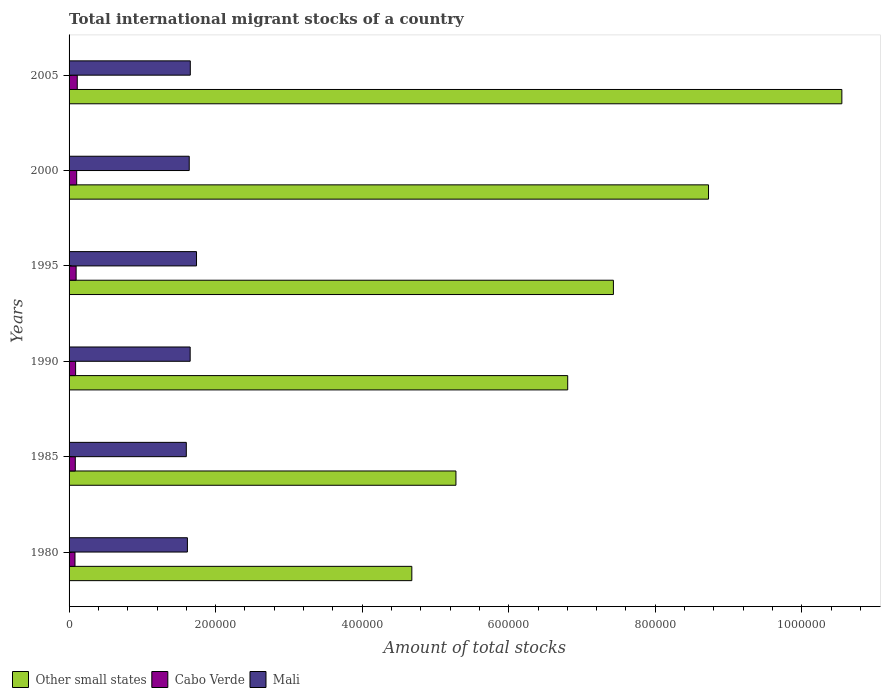How many different coloured bars are there?
Make the answer very short. 3. Are the number of bars per tick equal to the number of legend labels?
Make the answer very short. Yes. Are the number of bars on each tick of the Y-axis equal?
Provide a succinct answer. Yes. What is the label of the 1st group of bars from the top?
Your response must be concise. 2005. What is the amount of total stocks in in Mali in 1990?
Make the answer very short. 1.65e+05. Across all years, what is the maximum amount of total stocks in in Cabo Verde?
Give a very brief answer. 1.12e+04. Across all years, what is the minimum amount of total stocks in in Cabo Verde?
Your answer should be compact. 8080. In which year was the amount of total stocks in in Other small states maximum?
Provide a succinct answer. 2005. What is the total amount of total stocks in in Cabo Verde in the graph?
Your response must be concise. 5.67e+04. What is the difference between the amount of total stocks in in Other small states in 1985 and that in 2005?
Keep it short and to the point. -5.27e+05. What is the difference between the amount of total stocks in in Cabo Verde in 2005 and the amount of total stocks in in Mali in 1995?
Your answer should be compact. -1.63e+05. What is the average amount of total stocks in in Cabo Verde per year?
Your response must be concise. 9448.33. In the year 1990, what is the difference between the amount of total stocks in in Other small states and amount of total stocks in in Cabo Verde?
Your answer should be compact. 6.72e+05. In how many years, is the amount of total stocks in in Cabo Verde greater than 640000 ?
Keep it short and to the point. 0. What is the ratio of the amount of total stocks in in Mali in 1995 to that in 2005?
Provide a short and direct response. 1.05. Is the difference between the amount of total stocks in in Other small states in 1980 and 1985 greater than the difference between the amount of total stocks in in Cabo Verde in 1980 and 1985?
Give a very brief answer. No. What is the difference between the highest and the second highest amount of total stocks in in Mali?
Your response must be concise. 8494. What is the difference between the highest and the lowest amount of total stocks in in Mali?
Provide a short and direct response. 1.39e+04. Is the sum of the amount of total stocks in in Other small states in 1980 and 1990 greater than the maximum amount of total stocks in in Cabo Verde across all years?
Your answer should be compact. Yes. What does the 3rd bar from the top in 1995 represents?
Your answer should be very brief. Other small states. What does the 2nd bar from the bottom in 2005 represents?
Provide a short and direct response. Cabo Verde. Is it the case that in every year, the sum of the amount of total stocks in in Cabo Verde and amount of total stocks in in Mali is greater than the amount of total stocks in in Other small states?
Make the answer very short. No. Are all the bars in the graph horizontal?
Your answer should be compact. Yes. How many years are there in the graph?
Keep it short and to the point. 6. What is the difference between two consecutive major ticks on the X-axis?
Ensure brevity in your answer.  2.00e+05. Where does the legend appear in the graph?
Offer a very short reply. Bottom left. How are the legend labels stacked?
Offer a terse response. Horizontal. What is the title of the graph?
Offer a terse response. Total international migrant stocks of a country. What is the label or title of the X-axis?
Your response must be concise. Amount of total stocks. What is the label or title of the Y-axis?
Keep it short and to the point. Years. What is the Amount of total stocks in Other small states in 1980?
Provide a short and direct response. 4.68e+05. What is the Amount of total stocks of Cabo Verde in 1980?
Offer a very short reply. 8080. What is the Amount of total stocks in Mali in 1980?
Your answer should be very brief. 1.62e+05. What is the Amount of total stocks in Other small states in 1985?
Make the answer very short. 5.28e+05. What is the Amount of total stocks of Cabo Verde in 1985?
Provide a succinct answer. 8495. What is the Amount of total stocks of Mali in 1985?
Make the answer very short. 1.60e+05. What is the Amount of total stocks of Other small states in 1990?
Provide a short and direct response. 6.81e+05. What is the Amount of total stocks in Cabo Verde in 1990?
Make the answer very short. 8931. What is the Amount of total stocks of Mali in 1990?
Your response must be concise. 1.65e+05. What is the Amount of total stocks in Other small states in 1995?
Ensure brevity in your answer.  7.43e+05. What is the Amount of total stocks of Cabo Verde in 1995?
Give a very brief answer. 9626. What is the Amount of total stocks of Mali in 1995?
Offer a terse response. 1.74e+05. What is the Amount of total stocks in Other small states in 2000?
Offer a very short reply. 8.73e+05. What is the Amount of total stocks in Cabo Verde in 2000?
Your answer should be very brief. 1.04e+04. What is the Amount of total stocks of Mali in 2000?
Offer a very short reply. 1.64e+05. What is the Amount of total stocks in Other small states in 2005?
Your answer should be very brief. 1.05e+06. What is the Amount of total stocks in Cabo Verde in 2005?
Make the answer very short. 1.12e+04. What is the Amount of total stocks in Mali in 2005?
Give a very brief answer. 1.65e+05. Across all years, what is the maximum Amount of total stocks in Other small states?
Your response must be concise. 1.05e+06. Across all years, what is the maximum Amount of total stocks in Cabo Verde?
Offer a very short reply. 1.12e+04. Across all years, what is the maximum Amount of total stocks of Mali?
Ensure brevity in your answer.  1.74e+05. Across all years, what is the minimum Amount of total stocks in Other small states?
Your answer should be very brief. 4.68e+05. Across all years, what is the minimum Amount of total stocks of Cabo Verde?
Offer a very short reply. 8080. Across all years, what is the minimum Amount of total stocks in Mali?
Make the answer very short. 1.60e+05. What is the total Amount of total stocks of Other small states in the graph?
Give a very brief answer. 4.35e+06. What is the total Amount of total stocks in Cabo Verde in the graph?
Ensure brevity in your answer.  5.67e+04. What is the total Amount of total stocks in Mali in the graph?
Offer a very short reply. 9.90e+05. What is the difference between the Amount of total stocks in Other small states in 1980 and that in 1985?
Your answer should be compact. -6.02e+04. What is the difference between the Amount of total stocks in Cabo Verde in 1980 and that in 1985?
Offer a terse response. -415. What is the difference between the Amount of total stocks in Mali in 1980 and that in 1985?
Offer a terse response. 1487. What is the difference between the Amount of total stocks in Other small states in 1980 and that in 1990?
Offer a very short reply. -2.13e+05. What is the difference between the Amount of total stocks in Cabo Verde in 1980 and that in 1990?
Keep it short and to the point. -851. What is the difference between the Amount of total stocks in Mali in 1980 and that in 1990?
Offer a terse response. -3769. What is the difference between the Amount of total stocks of Other small states in 1980 and that in 1995?
Your answer should be very brief. -2.75e+05. What is the difference between the Amount of total stocks in Cabo Verde in 1980 and that in 1995?
Offer a very short reply. -1546. What is the difference between the Amount of total stocks in Mali in 1980 and that in 1995?
Keep it short and to the point. -1.24e+04. What is the difference between the Amount of total stocks of Other small states in 1980 and that in 2000?
Your answer should be compact. -4.05e+05. What is the difference between the Amount of total stocks of Cabo Verde in 1980 and that in 2000?
Your response must be concise. -2295. What is the difference between the Amount of total stocks in Mali in 1980 and that in 2000?
Give a very brief answer. -2488. What is the difference between the Amount of total stocks in Other small states in 1980 and that in 2005?
Your answer should be compact. -5.87e+05. What is the difference between the Amount of total stocks in Cabo Verde in 1980 and that in 2005?
Give a very brief answer. -3103. What is the difference between the Amount of total stocks of Mali in 1980 and that in 2005?
Your answer should be compact. -3942. What is the difference between the Amount of total stocks in Other small states in 1985 and that in 1990?
Make the answer very short. -1.53e+05. What is the difference between the Amount of total stocks in Cabo Verde in 1985 and that in 1990?
Give a very brief answer. -436. What is the difference between the Amount of total stocks of Mali in 1985 and that in 1990?
Keep it short and to the point. -5256. What is the difference between the Amount of total stocks in Other small states in 1985 and that in 1995?
Give a very brief answer. -2.15e+05. What is the difference between the Amount of total stocks in Cabo Verde in 1985 and that in 1995?
Give a very brief answer. -1131. What is the difference between the Amount of total stocks in Mali in 1985 and that in 1995?
Ensure brevity in your answer.  -1.39e+04. What is the difference between the Amount of total stocks in Other small states in 1985 and that in 2000?
Make the answer very short. -3.45e+05. What is the difference between the Amount of total stocks of Cabo Verde in 1985 and that in 2000?
Offer a terse response. -1880. What is the difference between the Amount of total stocks of Mali in 1985 and that in 2000?
Provide a succinct answer. -3975. What is the difference between the Amount of total stocks in Other small states in 1985 and that in 2005?
Make the answer very short. -5.27e+05. What is the difference between the Amount of total stocks of Cabo Verde in 1985 and that in 2005?
Your answer should be compact. -2688. What is the difference between the Amount of total stocks of Mali in 1985 and that in 2005?
Make the answer very short. -5429. What is the difference between the Amount of total stocks in Other small states in 1990 and that in 1995?
Keep it short and to the point. -6.24e+04. What is the difference between the Amount of total stocks of Cabo Verde in 1990 and that in 1995?
Give a very brief answer. -695. What is the difference between the Amount of total stocks in Mali in 1990 and that in 1995?
Keep it short and to the point. -8667. What is the difference between the Amount of total stocks in Other small states in 1990 and that in 2000?
Make the answer very short. -1.92e+05. What is the difference between the Amount of total stocks in Cabo Verde in 1990 and that in 2000?
Make the answer very short. -1444. What is the difference between the Amount of total stocks in Mali in 1990 and that in 2000?
Make the answer very short. 1281. What is the difference between the Amount of total stocks in Other small states in 1990 and that in 2005?
Keep it short and to the point. -3.74e+05. What is the difference between the Amount of total stocks of Cabo Verde in 1990 and that in 2005?
Keep it short and to the point. -2252. What is the difference between the Amount of total stocks of Mali in 1990 and that in 2005?
Provide a succinct answer. -173. What is the difference between the Amount of total stocks in Other small states in 1995 and that in 2000?
Your response must be concise. -1.30e+05. What is the difference between the Amount of total stocks of Cabo Verde in 1995 and that in 2000?
Offer a terse response. -749. What is the difference between the Amount of total stocks in Mali in 1995 and that in 2000?
Offer a very short reply. 9948. What is the difference between the Amount of total stocks in Other small states in 1995 and that in 2005?
Give a very brief answer. -3.12e+05. What is the difference between the Amount of total stocks of Cabo Verde in 1995 and that in 2005?
Give a very brief answer. -1557. What is the difference between the Amount of total stocks of Mali in 1995 and that in 2005?
Provide a succinct answer. 8494. What is the difference between the Amount of total stocks in Other small states in 2000 and that in 2005?
Provide a succinct answer. -1.82e+05. What is the difference between the Amount of total stocks of Cabo Verde in 2000 and that in 2005?
Ensure brevity in your answer.  -808. What is the difference between the Amount of total stocks of Mali in 2000 and that in 2005?
Give a very brief answer. -1454. What is the difference between the Amount of total stocks of Other small states in 1980 and the Amount of total stocks of Cabo Verde in 1985?
Your response must be concise. 4.59e+05. What is the difference between the Amount of total stocks in Other small states in 1980 and the Amount of total stocks in Mali in 1985?
Ensure brevity in your answer.  3.08e+05. What is the difference between the Amount of total stocks in Cabo Verde in 1980 and the Amount of total stocks in Mali in 1985?
Provide a succinct answer. -1.52e+05. What is the difference between the Amount of total stocks in Other small states in 1980 and the Amount of total stocks in Cabo Verde in 1990?
Your response must be concise. 4.59e+05. What is the difference between the Amount of total stocks of Other small states in 1980 and the Amount of total stocks of Mali in 1990?
Make the answer very short. 3.03e+05. What is the difference between the Amount of total stocks of Cabo Verde in 1980 and the Amount of total stocks of Mali in 1990?
Offer a very short reply. -1.57e+05. What is the difference between the Amount of total stocks in Other small states in 1980 and the Amount of total stocks in Cabo Verde in 1995?
Offer a very short reply. 4.58e+05. What is the difference between the Amount of total stocks in Other small states in 1980 and the Amount of total stocks in Mali in 1995?
Keep it short and to the point. 2.94e+05. What is the difference between the Amount of total stocks of Cabo Verde in 1980 and the Amount of total stocks of Mali in 1995?
Your answer should be compact. -1.66e+05. What is the difference between the Amount of total stocks of Other small states in 1980 and the Amount of total stocks of Cabo Verde in 2000?
Make the answer very short. 4.57e+05. What is the difference between the Amount of total stocks in Other small states in 1980 and the Amount of total stocks in Mali in 2000?
Provide a succinct answer. 3.04e+05. What is the difference between the Amount of total stocks of Cabo Verde in 1980 and the Amount of total stocks of Mali in 2000?
Your answer should be compact. -1.56e+05. What is the difference between the Amount of total stocks in Other small states in 1980 and the Amount of total stocks in Cabo Verde in 2005?
Ensure brevity in your answer.  4.57e+05. What is the difference between the Amount of total stocks in Other small states in 1980 and the Amount of total stocks in Mali in 2005?
Make the answer very short. 3.02e+05. What is the difference between the Amount of total stocks in Cabo Verde in 1980 and the Amount of total stocks in Mali in 2005?
Your response must be concise. -1.57e+05. What is the difference between the Amount of total stocks of Other small states in 1985 and the Amount of total stocks of Cabo Verde in 1990?
Your answer should be very brief. 5.19e+05. What is the difference between the Amount of total stocks of Other small states in 1985 and the Amount of total stocks of Mali in 1990?
Your answer should be compact. 3.63e+05. What is the difference between the Amount of total stocks in Cabo Verde in 1985 and the Amount of total stocks in Mali in 1990?
Your answer should be compact. -1.57e+05. What is the difference between the Amount of total stocks of Other small states in 1985 and the Amount of total stocks of Cabo Verde in 1995?
Provide a succinct answer. 5.18e+05. What is the difference between the Amount of total stocks of Other small states in 1985 and the Amount of total stocks of Mali in 1995?
Offer a terse response. 3.54e+05. What is the difference between the Amount of total stocks in Cabo Verde in 1985 and the Amount of total stocks in Mali in 1995?
Offer a very short reply. -1.65e+05. What is the difference between the Amount of total stocks of Other small states in 1985 and the Amount of total stocks of Cabo Verde in 2000?
Make the answer very short. 5.18e+05. What is the difference between the Amount of total stocks in Other small states in 1985 and the Amount of total stocks in Mali in 2000?
Provide a succinct answer. 3.64e+05. What is the difference between the Amount of total stocks in Cabo Verde in 1985 and the Amount of total stocks in Mali in 2000?
Your answer should be compact. -1.55e+05. What is the difference between the Amount of total stocks in Other small states in 1985 and the Amount of total stocks in Cabo Verde in 2005?
Provide a succinct answer. 5.17e+05. What is the difference between the Amount of total stocks of Other small states in 1985 and the Amount of total stocks of Mali in 2005?
Keep it short and to the point. 3.63e+05. What is the difference between the Amount of total stocks in Cabo Verde in 1985 and the Amount of total stocks in Mali in 2005?
Your response must be concise. -1.57e+05. What is the difference between the Amount of total stocks of Other small states in 1990 and the Amount of total stocks of Cabo Verde in 1995?
Make the answer very short. 6.71e+05. What is the difference between the Amount of total stocks in Other small states in 1990 and the Amount of total stocks in Mali in 1995?
Your response must be concise. 5.07e+05. What is the difference between the Amount of total stocks of Cabo Verde in 1990 and the Amount of total stocks of Mali in 1995?
Make the answer very short. -1.65e+05. What is the difference between the Amount of total stocks of Other small states in 1990 and the Amount of total stocks of Cabo Verde in 2000?
Your answer should be compact. 6.70e+05. What is the difference between the Amount of total stocks in Other small states in 1990 and the Amount of total stocks in Mali in 2000?
Provide a succinct answer. 5.17e+05. What is the difference between the Amount of total stocks of Cabo Verde in 1990 and the Amount of total stocks of Mali in 2000?
Provide a short and direct response. -1.55e+05. What is the difference between the Amount of total stocks in Other small states in 1990 and the Amount of total stocks in Cabo Verde in 2005?
Provide a short and direct response. 6.69e+05. What is the difference between the Amount of total stocks in Other small states in 1990 and the Amount of total stocks in Mali in 2005?
Give a very brief answer. 5.15e+05. What is the difference between the Amount of total stocks in Cabo Verde in 1990 and the Amount of total stocks in Mali in 2005?
Ensure brevity in your answer.  -1.57e+05. What is the difference between the Amount of total stocks in Other small states in 1995 and the Amount of total stocks in Cabo Verde in 2000?
Provide a succinct answer. 7.33e+05. What is the difference between the Amount of total stocks in Other small states in 1995 and the Amount of total stocks in Mali in 2000?
Ensure brevity in your answer.  5.79e+05. What is the difference between the Amount of total stocks in Cabo Verde in 1995 and the Amount of total stocks in Mali in 2000?
Your answer should be very brief. -1.54e+05. What is the difference between the Amount of total stocks of Other small states in 1995 and the Amount of total stocks of Cabo Verde in 2005?
Offer a terse response. 7.32e+05. What is the difference between the Amount of total stocks in Other small states in 1995 and the Amount of total stocks in Mali in 2005?
Give a very brief answer. 5.77e+05. What is the difference between the Amount of total stocks of Cabo Verde in 1995 and the Amount of total stocks of Mali in 2005?
Ensure brevity in your answer.  -1.56e+05. What is the difference between the Amount of total stocks of Other small states in 2000 and the Amount of total stocks of Cabo Verde in 2005?
Ensure brevity in your answer.  8.62e+05. What is the difference between the Amount of total stocks in Other small states in 2000 and the Amount of total stocks in Mali in 2005?
Give a very brief answer. 7.07e+05. What is the difference between the Amount of total stocks of Cabo Verde in 2000 and the Amount of total stocks of Mali in 2005?
Keep it short and to the point. -1.55e+05. What is the average Amount of total stocks of Other small states per year?
Your answer should be compact. 7.24e+05. What is the average Amount of total stocks of Cabo Verde per year?
Provide a short and direct response. 9448.33. What is the average Amount of total stocks of Mali per year?
Give a very brief answer. 1.65e+05. In the year 1980, what is the difference between the Amount of total stocks of Other small states and Amount of total stocks of Cabo Verde?
Keep it short and to the point. 4.60e+05. In the year 1980, what is the difference between the Amount of total stocks of Other small states and Amount of total stocks of Mali?
Provide a succinct answer. 3.06e+05. In the year 1980, what is the difference between the Amount of total stocks of Cabo Verde and Amount of total stocks of Mali?
Make the answer very short. -1.53e+05. In the year 1985, what is the difference between the Amount of total stocks in Other small states and Amount of total stocks in Cabo Verde?
Keep it short and to the point. 5.20e+05. In the year 1985, what is the difference between the Amount of total stocks in Other small states and Amount of total stocks in Mali?
Your answer should be very brief. 3.68e+05. In the year 1985, what is the difference between the Amount of total stocks in Cabo Verde and Amount of total stocks in Mali?
Give a very brief answer. -1.52e+05. In the year 1990, what is the difference between the Amount of total stocks of Other small states and Amount of total stocks of Cabo Verde?
Give a very brief answer. 6.72e+05. In the year 1990, what is the difference between the Amount of total stocks in Other small states and Amount of total stocks in Mali?
Your response must be concise. 5.15e+05. In the year 1990, what is the difference between the Amount of total stocks in Cabo Verde and Amount of total stocks in Mali?
Your answer should be compact. -1.56e+05. In the year 1995, what is the difference between the Amount of total stocks of Other small states and Amount of total stocks of Cabo Verde?
Offer a very short reply. 7.33e+05. In the year 1995, what is the difference between the Amount of total stocks of Other small states and Amount of total stocks of Mali?
Your response must be concise. 5.69e+05. In the year 1995, what is the difference between the Amount of total stocks of Cabo Verde and Amount of total stocks of Mali?
Offer a very short reply. -1.64e+05. In the year 2000, what is the difference between the Amount of total stocks in Other small states and Amount of total stocks in Cabo Verde?
Make the answer very short. 8.62e+05. In the year 2000, what is the difference between the Amount of total stocks of Other small states and Amount of total stocks of Mali?
Keep it short and to the point. 7.09e+05. In the year 2000, what is the difference between the Amount of total stocks in Cabo Verde and Amount of total stocks in Mali?
Give a very brief answer. -1.54e+05. In the year 2005, what is the difference between the Amount of total stocks of Other small states and Amount of total stocks of Cabo Verde?
Keep it short and to the point. 1.04e+06. In the year 2005, what is the difference between the Amount of total stocks of Other small states and Amount of total stocks of Mali?
Keep it short and to the point. 8.89e+05. In the year 2005, what is the difference between the Amount of total stocks in Cabo Verde and Amount of total stocks in Mali?
Your answer should be very brief. -1.54e+05. What is the ratio of the Amount of total stocks of Other small states in 1980 to that in 1985?
Make the answer very short. 0.89. What is the ratio of the Amount of total stocks of Cabo Verde in 1980 to that in 1985?
Your response must be concise. 0.95. What is the ratio of the Amount of total stocks in Mali in 1980 to that in 1985?
Offer a terse response. 1.01. What is the ratio of the Amount of total stocks of Other small states in 1980 to that in 1990?
Keep it short and to the point. 0.69. What is the ratio of the Amount of total stocks of Cabo Verde in 1980 to that in 1990?
Give a very brief answer. 0.9. What is the ratio of the Amount of total stocks in Mali in 1980 to that in 1990?
Ensure brevity in your answer.  0.98. What is the ratio of the Amount of total stocks in Other small states in 1980 to that in 1995?
Your answer should be very brief. 0.63. What is the ratio of the Amount of total stocks of Cabo Verde in 1980 to that in 1995?
Your response must be concise. 0.84. What is the ratio of the Amount of total stocks of Mali in 1980 to that in 1995?
Provide a succinct answer. 0.93. What is the ratio of the Amount of total stocks of Other small states in 1980 to that in 2000?
Your answer should be very brief. 0.54. What is the ratio of the Amount of total stocks in Cabo Verde in 1980 to that in 2000?
Keep it short and to the point. 0.78. What is the ratio of the Amount of total stocks in Other small states in 1980 to that in 2005?
Offer a very short reply. 0.44. What is the ratio of the Amount of total stocks of Cabo Verde in 1980 to that in 2005?
Your answer should be compact. 0.72. What is the ratio of the Amount of total stocks of Mali in 1980 to that in 2005?
Your answer should be compact. 0.98. What is the ratio of the Amount of total stocks in Other small states in 1985 to that in 1990?
Your answer should be compact. 0.78. What is the ratio of the Amount of total stocks in Cabo Verde in 1985 to that in 1990?
Offer a terse response. 0.95. What is the ratio of the Amount of total stocks of Mali in 1985 to that in 1990?
Offer a very short reply. 0.97. What is the ratio of the Amount of total stocks in Other small states in 1985 to that in 1995?
Provide a succinct answer. 0.71. What is the ratio of the Amount of total stocks in Cabo Verde in 1985 to that in 1995?
Keep it short and to the point. 0.88. What is the ratio of the Amount of total stocks of Other small states in 1985 to that in 2000?
Your response must be concise. 0.6. What is the ratio of the Amount of total stocks in Cabo Verde in 1985 to that in 2000?
Give a very brief answer. 0.82. What is the ratio of the Amount of total stocks in Mali in 1985 to that in 2000?
Keep it short and to the point. 0.98. What is the ratio of the Amount of total stocks of Other small states in 1985 to that in 2005?
Provide a short and direct response. 0.5. What is the ratio of the Amount of total stocks of Cabo Verde in 1985 to that in 2005?
Make the answer very short. 0.76. What is the ratio of the Amount of total stocks in Mali in 1985 to that in 2005?
Make the answer very short. 0.97. What is the ratio of the Amount of total stocks of Other small states in 1990 to that in 1995?
Your answer should be very brief. 0.92. What is the ratio of the Amount of total stocks of Cabo Verde in 1990 to that in 1995?
Your response must be concise. 0.93. What is the ratio of the Amount of total stocks of Mali in 1990 to that in 1995?
Keep it short and to the point. 0.95. What is the ratio of the Amount of total stocks in Other small states in 1990 to that in 2000?
Ensure brevity in your answer.  0.78. What is the ratio of the Amount of total stocks of Cabo Verde in 1990 to that in 2000?
Make the answer very short. 0.86. What is the ratio of the Amount of total stocks of Mali in 1990 to that in 2000?
Offer a very short reply. 1.01. What is the ratio of the Amount of total stocks in Other small states in 1990 to that in 2005?
Your answer should be compact. 0.65. What is the ratio of the Amount of total stocks of Cabo Verde in 1990 to that in 2005?
Your answer should be very brief. 0.8. What is the ratio of the Amount of total stocks of Mali in 1990 to that in 2005?
Provide a succinct answer. 1. What is the ratio of the Amount of total stocks in Other small states in 1995 to that in 2000?
Offer a very short reply. 0.85. What is the ratio of the Amount of total stocks in Cabo Verde in 1995 to that in 2000?
Offer a very short reply. 0.93. What is the ratio of the Amount of total stocks of Mali in 1995 to that in 2000?
Provide a succinct answer. 1.06. What is the ratio of the Amount of total stocks of Other small states in 1995 to that in 2005?
Offer a very short reply. 0.7. What is the ratio of the Amount of total stocks of Cabo Verde in 1995 to that in 2005?
Provide a succinct answer. 0.86. What is the ratio of the Amount of total stocks of Mali in 1995 to that in 2005?
Ensure brevity in your answer.  1.05. What is the ratio of the Amount of total stocks in Other small states in 2000 to that in 2005?
Provide a short and direct response. 0.83. What is the ratio of the Amount of total stocks of Cabo Verde in 2000 to that in 2005?
Keep it short and to the point. 0.93. What is the difference between the highest and the second highest Amount of total stocks in Other small states?
Make the answer very short. 1.82e+05. What is the difference between the highest and the second highest Amount of total stocks of Cabo Verde?
Ensure brevity in your answer.  808. What is the difference between the highest and the second highest Amount of total stocks of Mali?
Provide a short and direct response. 8494. What is the difference between the highest and the lowest Amount of total stocks in Other small states?
Your answer should be compact. 5.87e+05. What is the difference between the highest and the lowest Amount of total stocks in Cabo Verde?
Keep it short and to the point. 3103. What is the difference between the highest and the lowest Amount of total stocks of Mali?
Offer a terse response. 1.39e+04. 